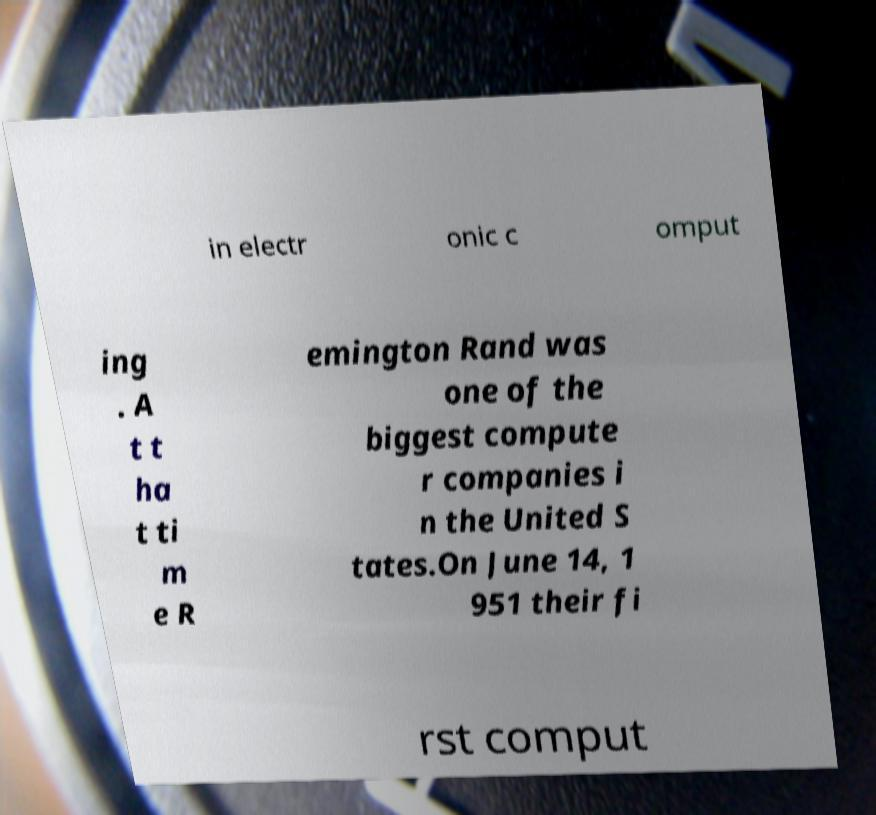Could you extract and type out the text from this image? in electr onic c omput ing . A t t ha t ti m e R emington Rand was one of the biggest compute r companies i n the United S tates.On June 14, 1 951 their fi rst comput 